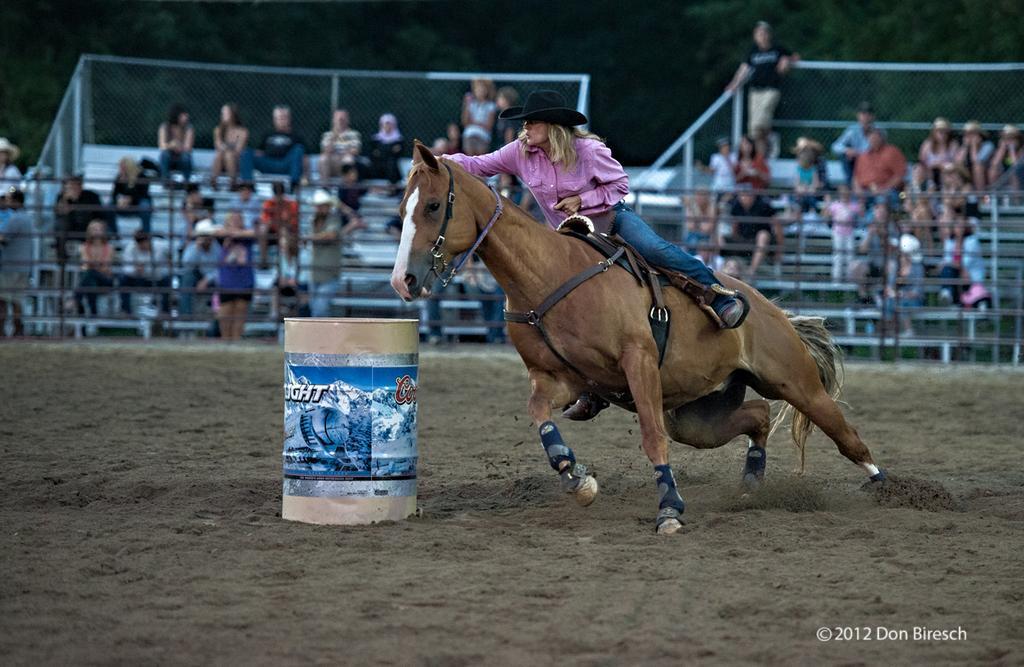Describe this image in one or two sentences. In this image I can see a woman wearing a pink color t-shirt, riding on horse on the ground and I can see a container visible in front of the horse and I can see there are few audience visible performance of the woman in the middle. 